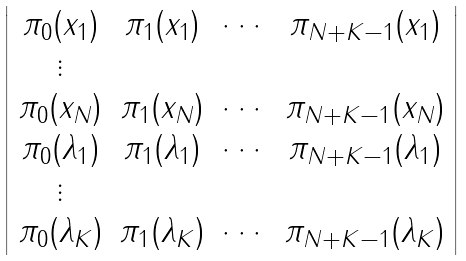Convert formula to latex. <formula><loc_0><loc_0><loc_500><loc_500>\left | \begin{array} { c c c c } \pi _ { 0 } ( x _ { 1 } ) & \pi _ { 1 } ( x _ { 1 } ) & \cdots & \pi _ { N + K - 1 } ( x _ { 1 } ) \\ \vdots & & & \\ \pi _ { 0 } ( x _ { N } ) & \pi _ { 1 } ( x _ { N } ) & \cdots & \pi _ { N + K - 1 } ( x _ { N } ) \\ \pi _ { 0 } ( \lambda _ { 1 } ) & \pi _ { 1 } ( \lambda _ { 1 } ) & \cdots & \pi _ { N + K - 1 } ( \lambda _ { 1 } ) \\ \vdots & & & \\ \pi _ { 0 } ( \lambda _ { K } ) & \pi _ { 1 } ( \lambda _ { K } ) & \cdots & \pi _ { N + K - 1 } ( \lambda _ { K } ) \end{array} \right |</formula> 